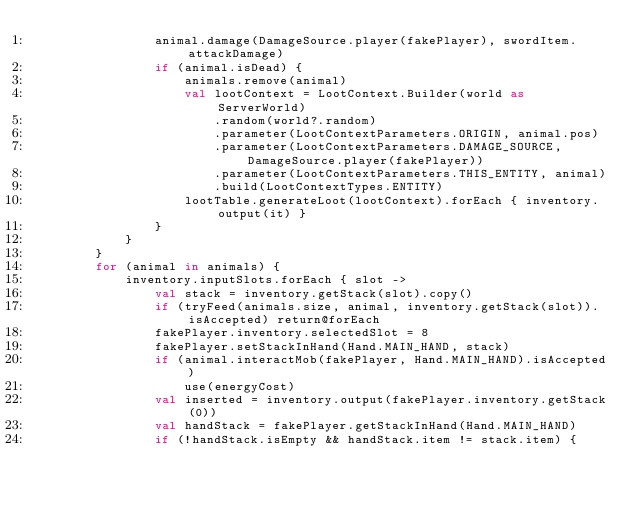<code> <loc_0><loc_0><loc_500><loc_500><_Kotlin_>                animal.damage(DamageSource.player(fakePlayer), swordItem.attackDamage)
                if (animal.isDead) {
                    animals.remove(animal)
                    val lootContext = LootContext.Builder(world as ServerWorld)
                        .random(world?.random)
                        .parameter(LootContextParameters.ORIGIN, animal.pos)
                        .parameter(LootContextParameters.DAMAGE_SOURCE, DamageSource.player(fakePlayer))
                        .parameter(LootContextParameters.THIS_ENTITY, animal)
                        .build(LootContextTypes.ENTITY)
                    lootTable.generateLoot(lootContext).forEach { inventory.output(it) }
                }
            }
        }
        for (animal in animals) {
            inventory.inputSlots.forEach { slot ->
                val stack = inventory.getStack(slot).copy()
                if (tryFeed(animals.size, animal, inventory.getStack(slot)).isAccepted) return@forEach
                fakePlayer.inventory.selectedSlot = 8
                fakePlayer.setStackInHand(Hand.MAIN_HAND, stack)
                if (animal.interactMob(fakePlayer, Hand.MAIN_HAND).isAccepted)
                    use(energyCost)
                val inserted = inventory.output(fakePlayer.inventory.getStack(0))
                val handStack = fakePlayer.getStackInHand(Hand.MAIN_HAND)
                if (!handStack.isEmpty && handStack.item != stack.item) {</code> 